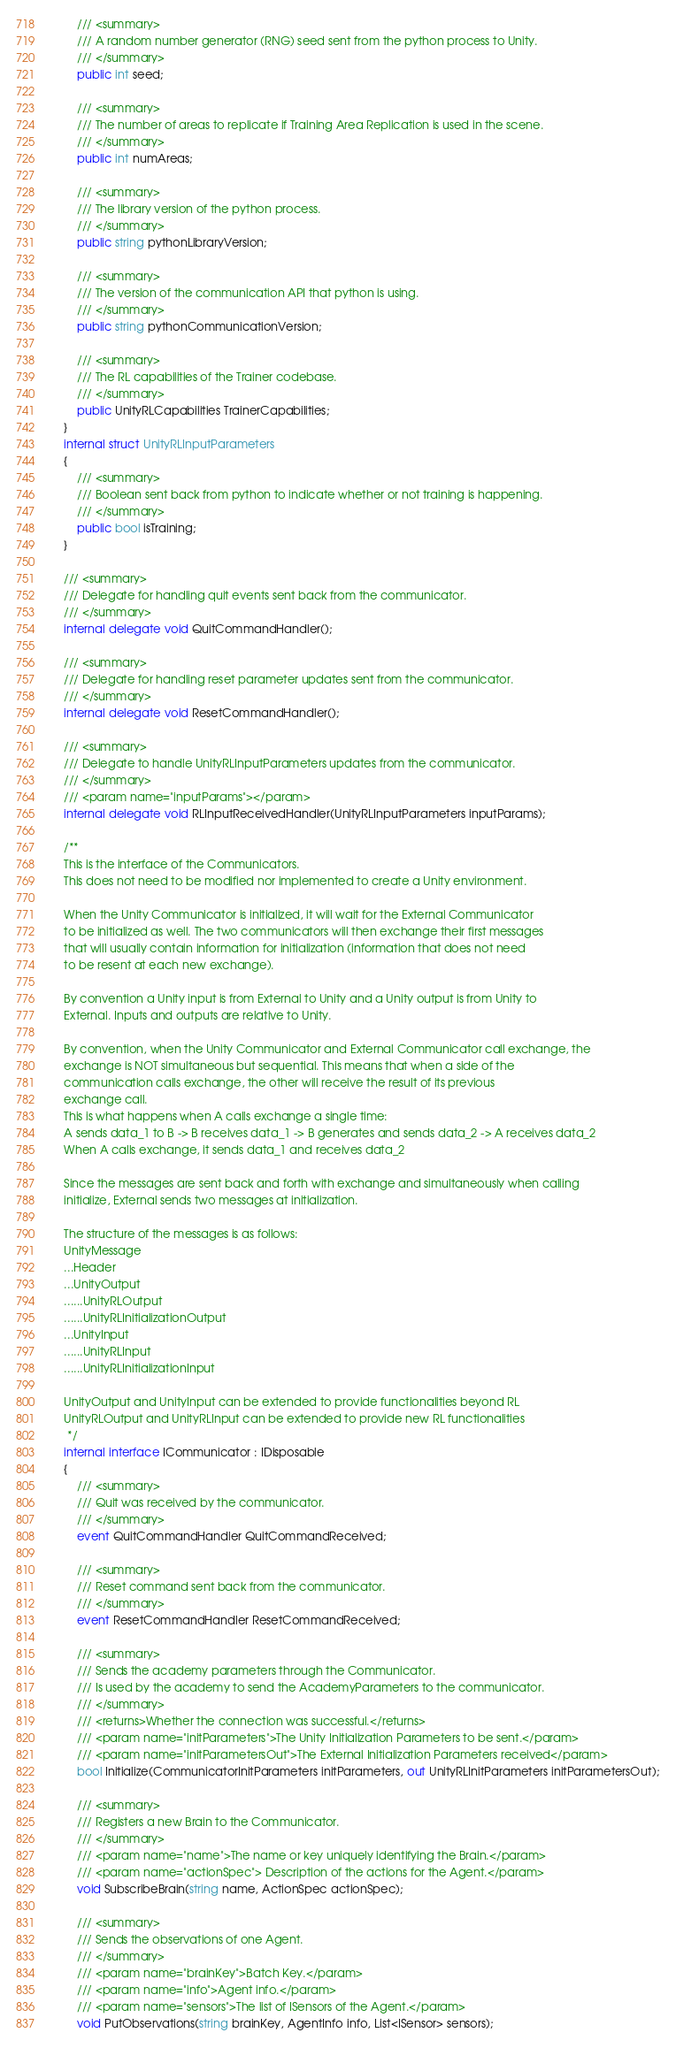<code> <loc_0><loc_0><loc_500><loc_500><_C#_>        /// <summary>
        /// A random number generator (RNG) seed sent from the python process to Unity.
        /// </summary>
        public int seed;

        /// <summary>
        /// The number of areas to replicate if Training Area Replication is used in the scene.
        /// </summary>
        public int numAreas;

        /// <summary>
        /// The library version of the python process.
        /// </summary>
        public string pythonLibraryVersion;

        /// <summary>
        /// The version of the communication API that python is using.
        /// </summary>
        public string pythonCommunicationVersion;

        /// <summary>
        /// The RL capabilities of the Trainer codebase.
        /// </summary>
        public UnityRLCapabilities TrainerCapabilities;
    }
    internal struct UnityRLInputParameters
    {
        /// <summary>
        /// Boolean sent back from python to indicate whether or not training is happening.
        /// </summary>
        public bool isTraining;
    }

    /// <summary>
    /// Delegate for handling quit events sent back from the communicator.
    /// </summary>
    internal delegate void QuitCommandHandler();

    /// <summary>
    /// Delegate for handling reset parameter updates sent from the communicator.
    /// </summary>
    internal delegate void ResetCommandHandler();

    /// <summary>
    /// Delegate to handle UnityRLInputParameters updates from the communicator.
    /// </summary>
    /// <param name="inputParams"></param>
    internal delegate void RLInputReceivedHandler(UnityRLInputParameters inputParams);

    /**
    This is the interface of the Communicators.
    This does not need to be modified nor implemented to create a Unity environment.

    When the Unity Communicator is initialized, it will wait for the External Communicator
    to be initialized as well. The two communicators will then exchange their first messages
    that will usually contain information for initialization (information that does not need
    to be resent at each new exchange).

    By convention a Unity input is from External to Unity and a Unity output is from Unity to
    External. Inputs and outputs are relative to Unity.

    By convention, when the Unity Communicator and External Communicator call exchange, the
    exchange is NOT simultaneous but sequential. This means that when a side of the
    communication calls exchange, the other will receive the result of its previous
    exchange call.
    This is what happens when A calls exchange a single time:
    A sends data_1 to B -> B receives data_1 -> B generates and sends data_2 -> A receives data_2
    When A calls exchange, it sends data_1 and receives data_2

    Since the messages are sent back and forth with exchange and simultaneously when calling
    initialize, External sends two messages at initialization.

    The structure of the messages is as follows:
    UnityMessage
    ...Header
    ...UnityOutput
    ......UnityRLOutput
    ......UnityRLInitializationOutput
    ...UnityInput
    ......UnityRLInput
    ......UnityRLInitializationInput

    UnityOutput and UnityInput can be extended to provide functionalities beyond RL
    UnityRLOutput and UnityRLInput can be extended to provide new RL functionalities
     */
    internal interface ICommunicator : IDisposable
    {
        /// <summary>
        /// Quit was received by the communicator.
        /// </summary>
        event QuitCommandHandler QuitCommandReceived;

        /// <summary>
        /// Reset command sent back from the communicator.
        /// </summary>
        event ResetCommandHandler ResetCommandReceived;

        /// <summary>
        /// Sends the academy parameters through the Communicator.
        /// Is used by the academy to send the AcademyParameters to the communicator.
        /// </summary>
        /// <returns>Whether the connection was successful.</returns>
        /// <param name="initParameters">The Unity Initialization Parameters to be sent.</param>
        /// <param name="initParametersOut">The External Initialization Parameters received</param>
        bool Initialize(CommunicatorInitParameters initParameters, out UnityRLInitParameters initParametersOut);

        /// <summary>
        /// Registers a new Brain to the Communicator.
        /// </summary>
        /// <param name="name">The name or key uniquely identifying the Brain.</param>
        /// <param name="actionSpec"> Description of the actions for the Agent.</param>
        void SubscribeBrain(string name, ActionSpec actionSpec);

        /// <summary>
        /// Sends the observations of one Agent.
        /// </summary>
        /// <param name="brainKey">Batch Key.</param>
        /// <param name="info">Agent info.</param>
        /// <param name="sensors">The list of ISensors of the Agent.</param>
        void PutObservations(string brainKey, AgentInfo info, List<ISensor> sensors);
</code> 